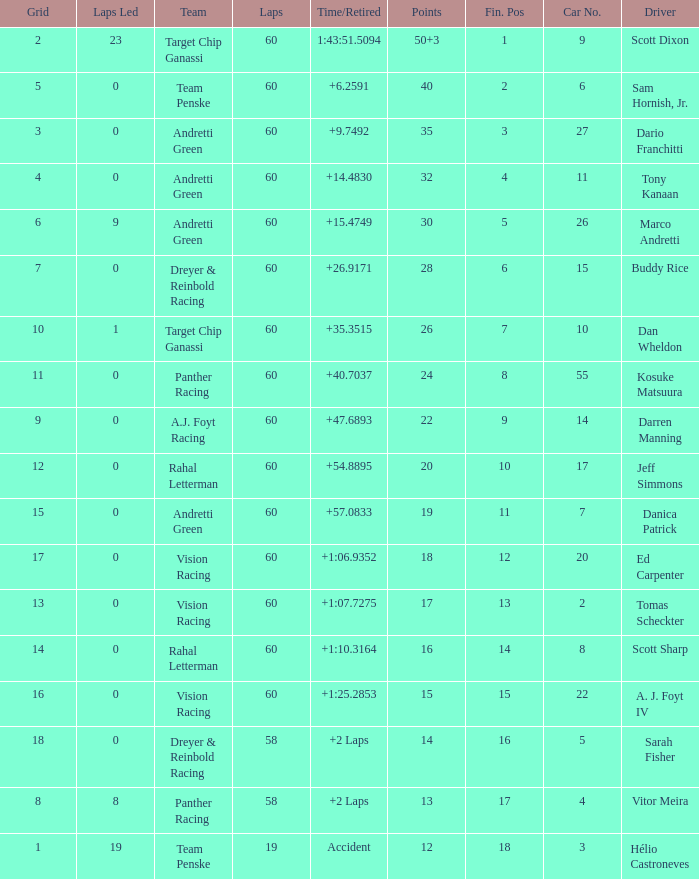Identify the squad of darren manning. A.J. Foyt Racing. 